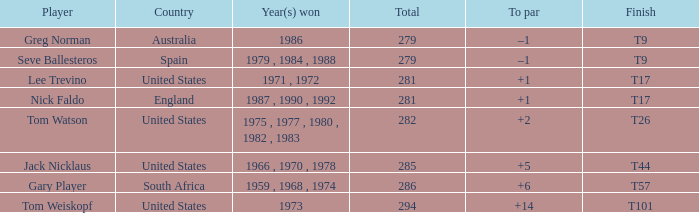What is Australia's to par? –1. 